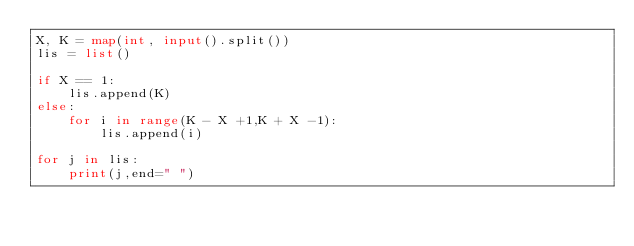Convert code to text. <code><loc_0><loc_0><loc_500><loc_500><_Python_>X, K = map(int, input().split())
lis = list()

if X == 1:
    lis.append(K)
else:
    for i in range(K - X +1,K + X -1):
        lis.append(i)

for j in lis:
    print(j,end=" ")</code> 